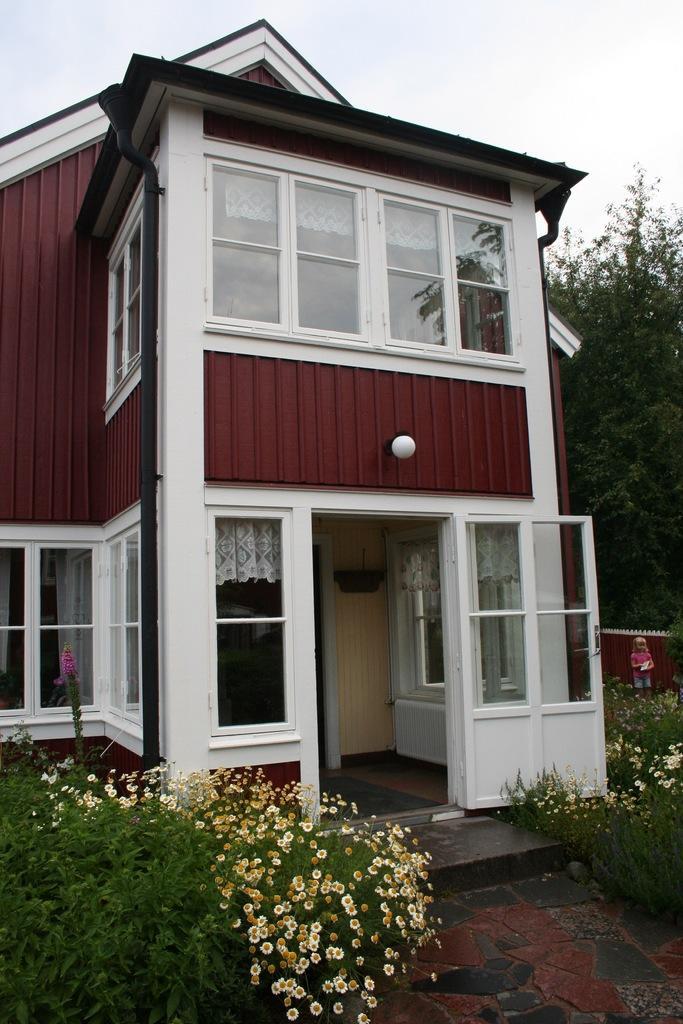How would you summarize this image in a sentence or two? In this image there is a house to that house there are glass windows and a door in front of the house there are plants, in the background there is a kid standing near a wall and there is a tree. 